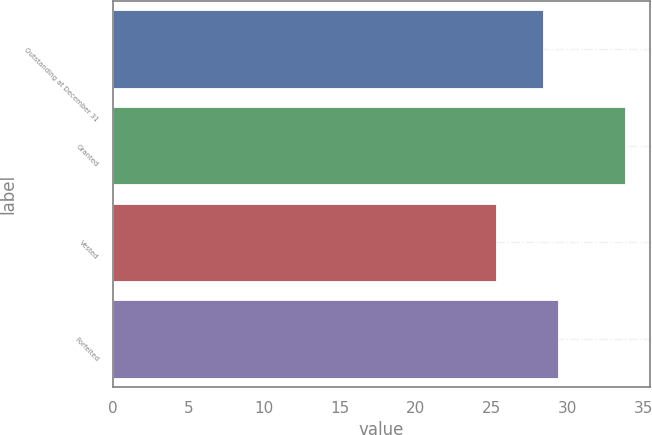<chart> <loc_0><loc_0><loc_500><loc_500><bar_chart><fcel>Outstanding at December 31<fcel>Granted<fcel>Vested<fcel>Forfeited<nl><fcel>28.41<fcel>33.77<fcel>25.29<fcel>29.35<nl></chart> 